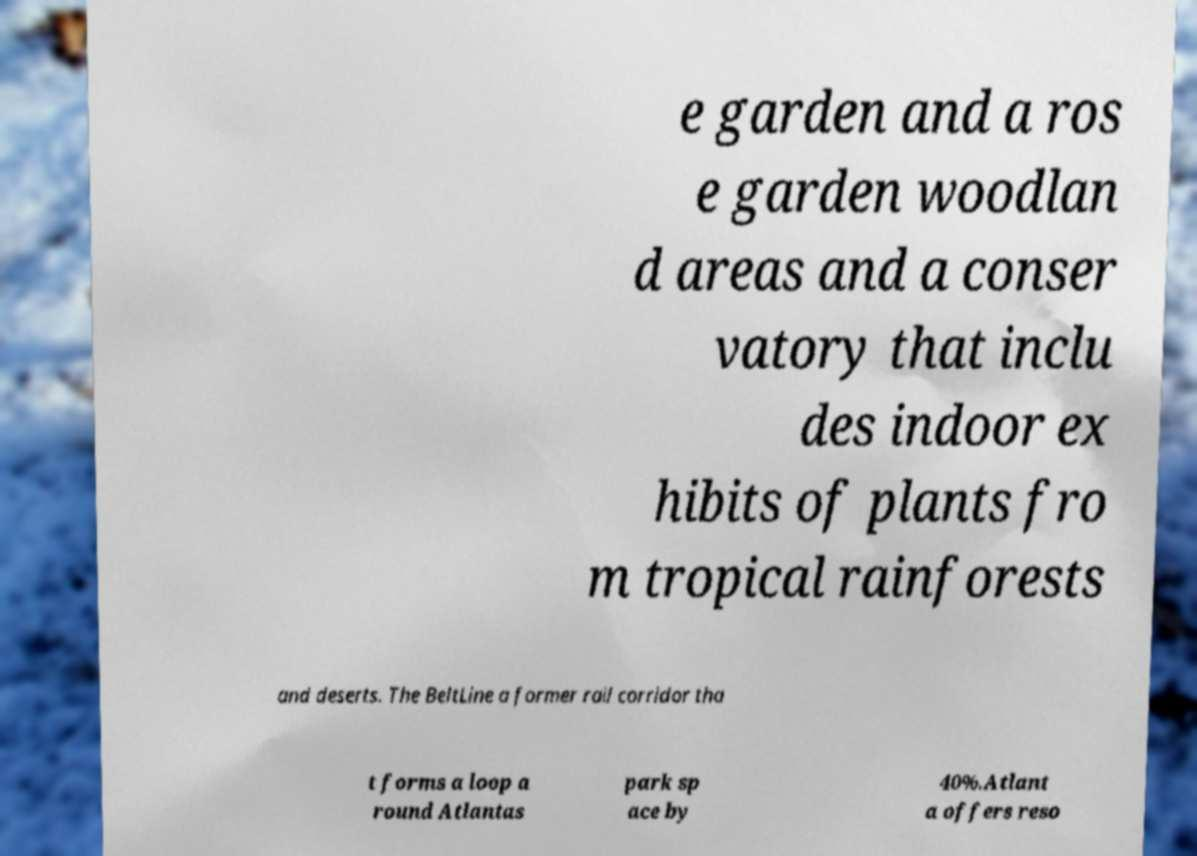Could you assist in decoding the text presented in this image and type it out clearly? e garden and a ros e garden woodlan d areas and a conser vatory that inclu des indoor ex hibits of plants fro m tropical rainforests and deserts. The BeltLine a former rail corridor tha t forms a loop a round Atlantas park sp ace by 40%.Atlant a offers reso 